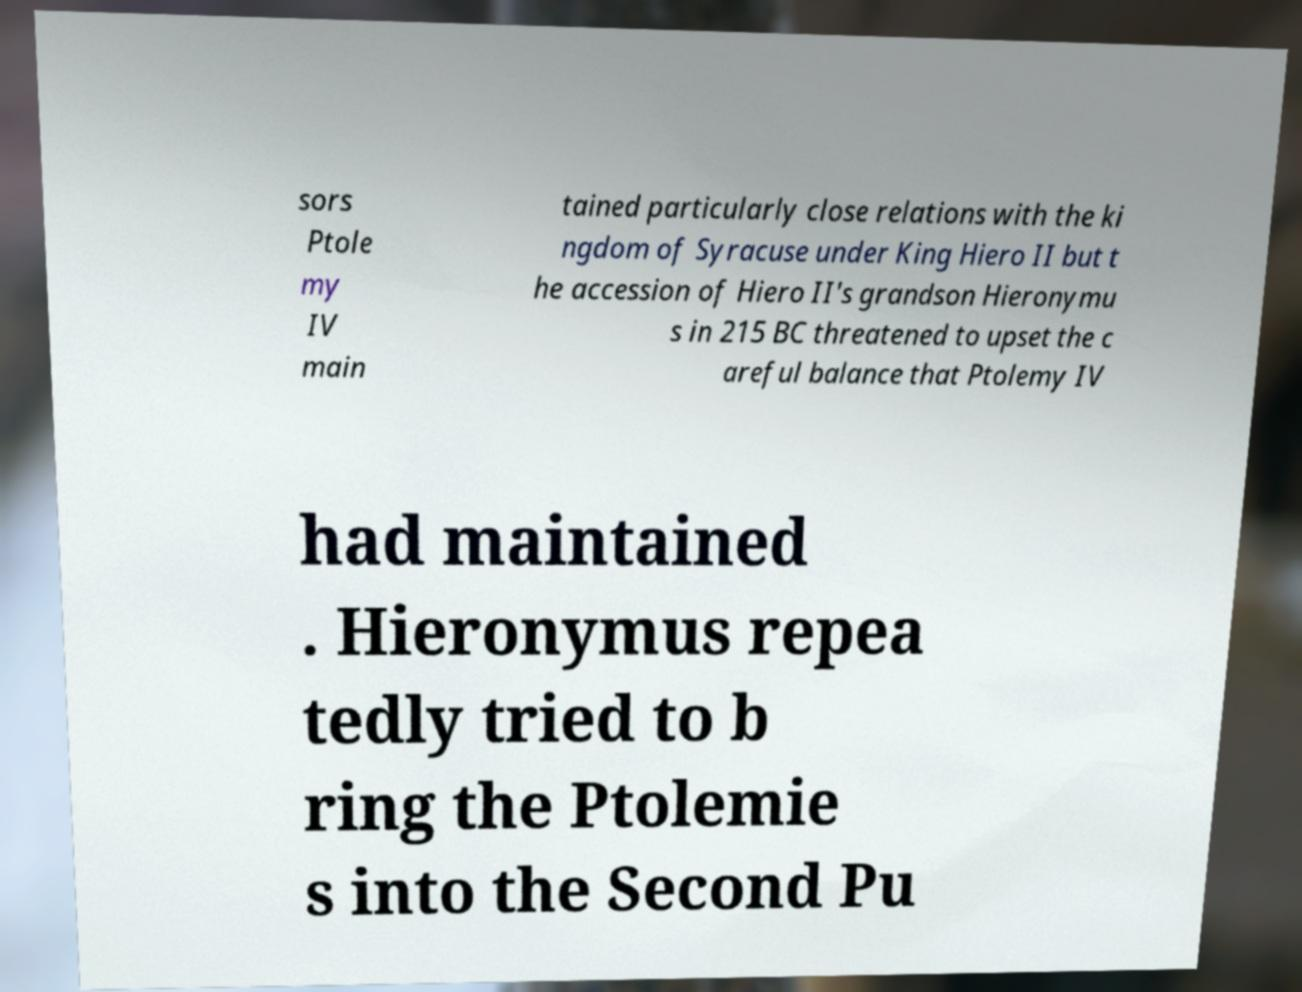What messages or text are displayed in this image? I need them in a readable, typed format. sors Ptole my IV main tained particularly close relations with the ki ngdom of Syracuse under King Hiero II but t he accession of Hiero II's grandson Hieronymu s in 215 BC threatened to upset the c areful balance that Ptolemy IV had maintained . Hieronymus repea tedly tried to b ring the Ptolemie s into the Second Pu 